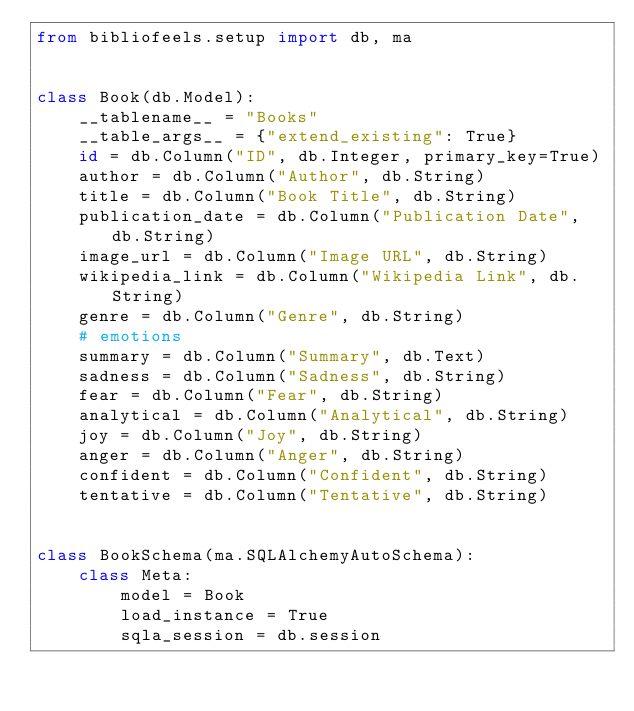<code> <loc_0><loc_0><loc_500><loc_500><_Python_>from bibliofeels.setup import db, ma


class Book(db.Model):
    __tablename__ = "Books"
    __table_args__ = {"extend_existing": True}
    id = db.Column("ID", db.Integer, primary_key=True)
    author = db.Column("Author", db.String)
    title = db.Column("Book Title", db.String)
    publication_date = db.Column("Publication Date", db.String)
    image_url = db.Column("Image URL", db.String)
    wikipedia_link = db.Column("Wikipedia Link", db.String)
    genre = db.Column("Genre", db.String)
    # emotions
    summary = db.Column("Summary", db.Text)
    sadness = db.Column("Sadness", db.String)
    fear = db.Column("Fear", db.String)
    analytical = db.Column("Analytical", db.String)
    joy = db.Column("Joy", db.String)
    anger = db.Column("Anger", db.String)
    confident = db.Column("Confident", db.String)
    tentative = db.Column("Tentative", db.String)


class BookSchema(ma.SQLAlchemyAutoSchema):
    class Meta:
        model = Book
        load_instance = True
        sqla_session = db.session
</code> 